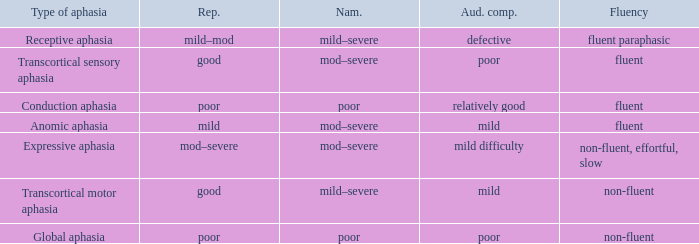Name the fluency for transcortical sensory aphasia Fluent. 